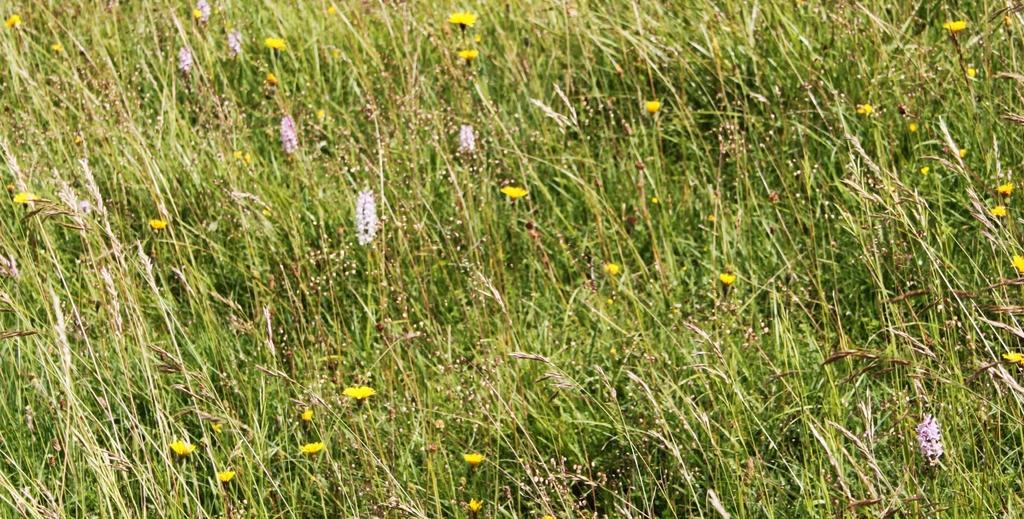Could you give a brief overview of what you see in this image? In this picture there is grass field in the image. 